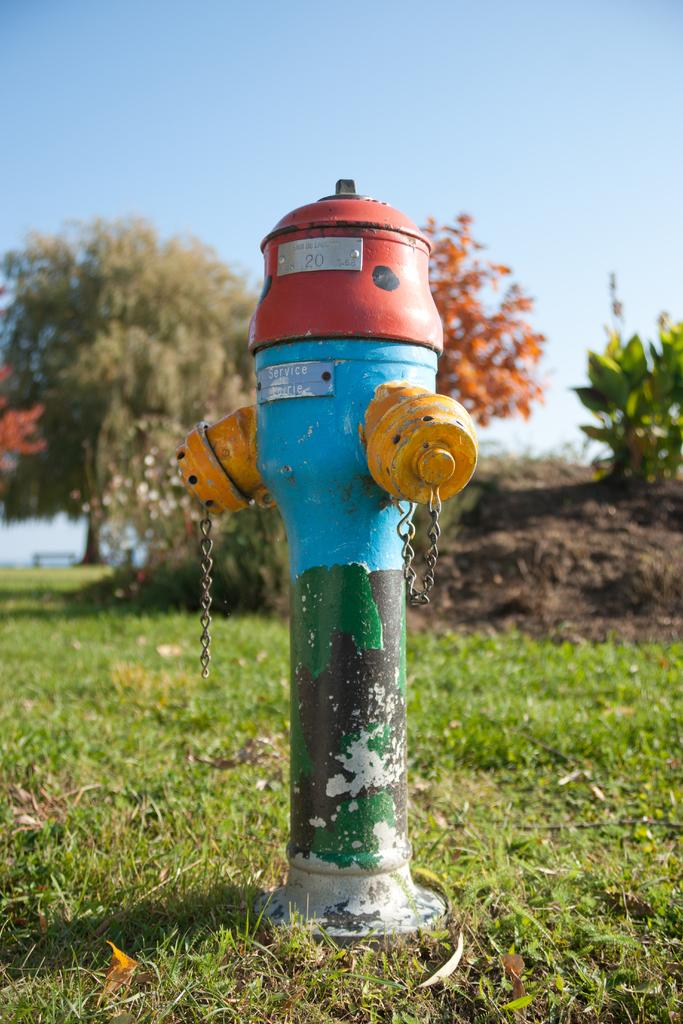<image>
Present a compact description of the photo's key features. A colorful painted fire hydrant with #20 and Service on the side. 